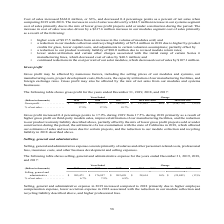According to First Solar's financial document, What are the components in selling, general and administrative expense? Selling, general and administrative expense consists primarily of salaries and other personnel-related costs, professional fees, insurance costs, and other business development and selling expenses.. The document states: "Selling, general and administrative expense consists primarily of salaries and other personnel-related costs, professional fees, insurance costs, and ..." Also, What are the reasons for higher selling, general and administrative expense in 2019 as compared to 2018? Selling, general and administrative expense in 2019 increased compared to 2018 primarily due to higher employee compensation expense, lower accretion expense in 2018 associated with the reduction in our module collection and recycling liability described above, and higher professional fees.. The document states: "Selling, general and administrative expense in 2019 increased compared to 2018 primarily due to higher employee compensation expense, lower accretion ..." Also, What is the percentage of net sales in 2019? According to the financial document, 6.7%. The relevant text states: "% of net sales . 6.7% 7.9% 6.9%..." Also, can you calculate: What is the amount of net sales in 2019? Based on the calculation: 205,471 / 6.7% , the result is 3066731.34 (in thousands). This is based on the information: "Selling, general and administrative . $ 205,471 $ 176,857 $ 202,699 $ 28,614 16% $ (25,842) (13)% % of net sales . 6.7% 7.9% 6.9%..." The key data points involved are: 205,471, 6.7. Also, can you calculate: What is the net difference in selling, general and administrative expense between 2019 and 2017? Based on the calculation: 205,471 - 202,699 , the result is 2772 (in thousands). This is based on the information: "Selling, general and administrative . $ 205,471 $ 176,857 $ 202,699 $ 28,614 16% $ (25,842) (13)% eneral and administrative . $ 205,471 $ 176,857 $ 202,699 $ 28,614 16% $ (25,842) (13)%..." The key data points involved are: 202,699, 205,471. Also, can you calculate: What is the difference in net sales amount in 2019 and 2018? To answer this question, I need to perform calculations using the financial data. The calculation is: (205,471 / 6.7%) - (176,857 / 7.9%) , which equals 828035.14 (in thousands). This is based on the information: "Selling, general and administrative . $ 205,471 $ 176,857 $ 202,699 $ 28,614 16% $ (25,842) (13)% % of net sales . 6.7% 7.9% 6.9% % of net sales . 6.7% 7.9% 6.9% Selling, general and administrative . ..." The key data points involved are: 176,857, 205,471, 6.7. 